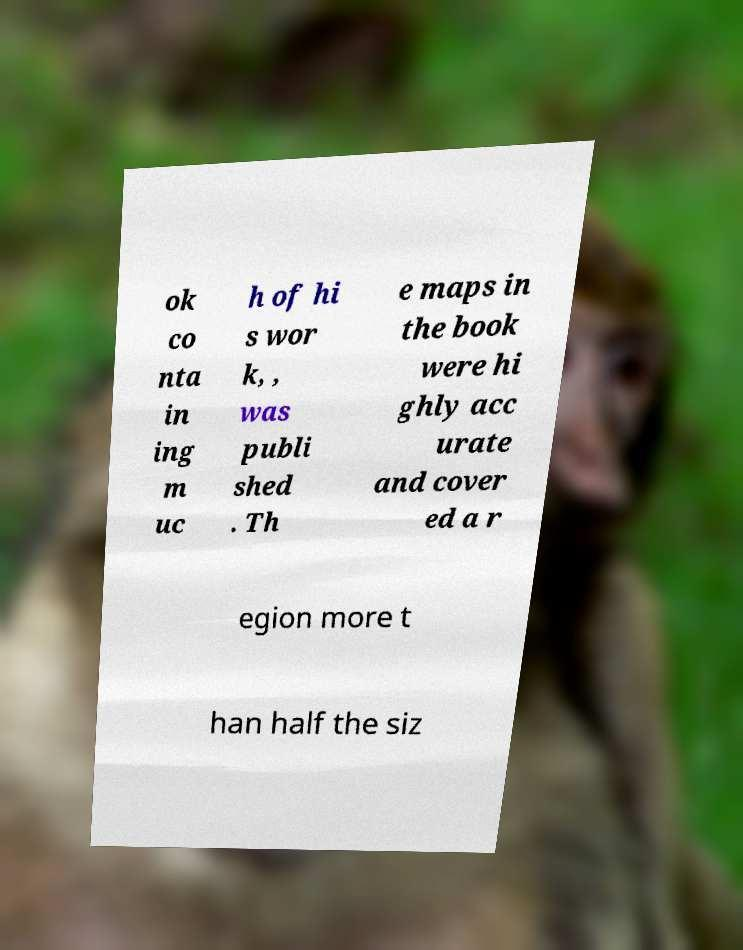What messages or text are displayed in this image? I need them in a readable, typed format. ok co nta in ing m uc h of hi s wor k, , was publi shed . Th e maps in the book were hi ghly acc urate and cover ed a r egion more t han half the siz 